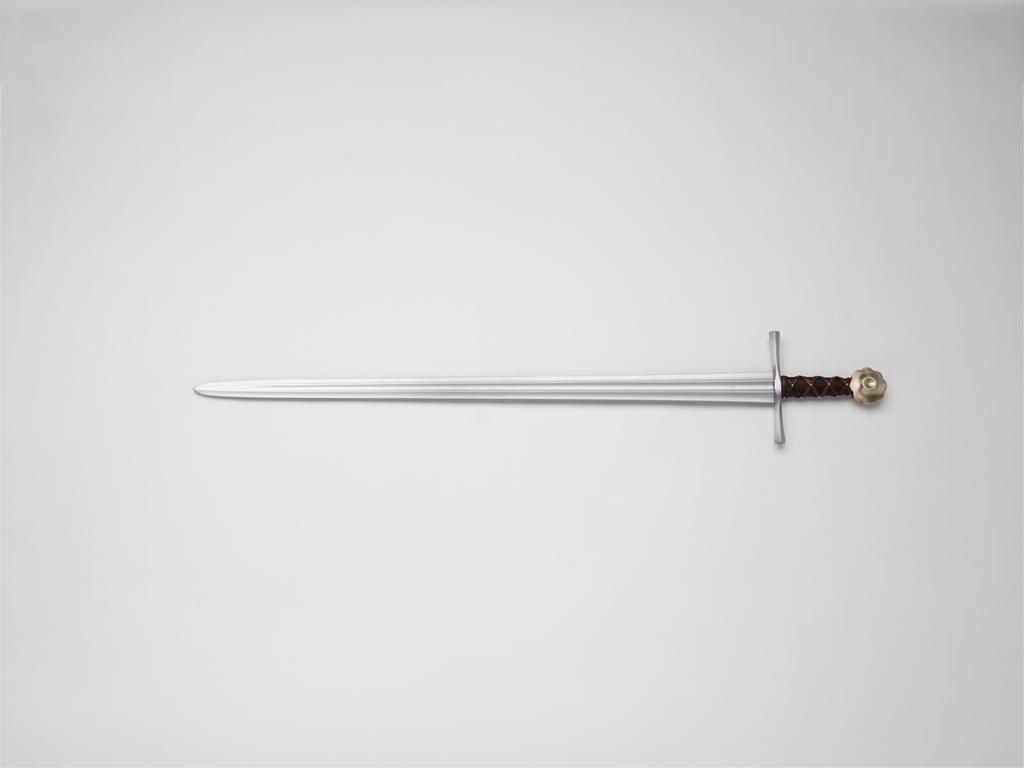What object can be seen in the image? There is a sword in the image. Where is the sword placed? The sword is kept on a surface. What type of duck can be seen swimming in the sun in the image? There is no duck or sun present in the image; it only features a sword on a surface. 